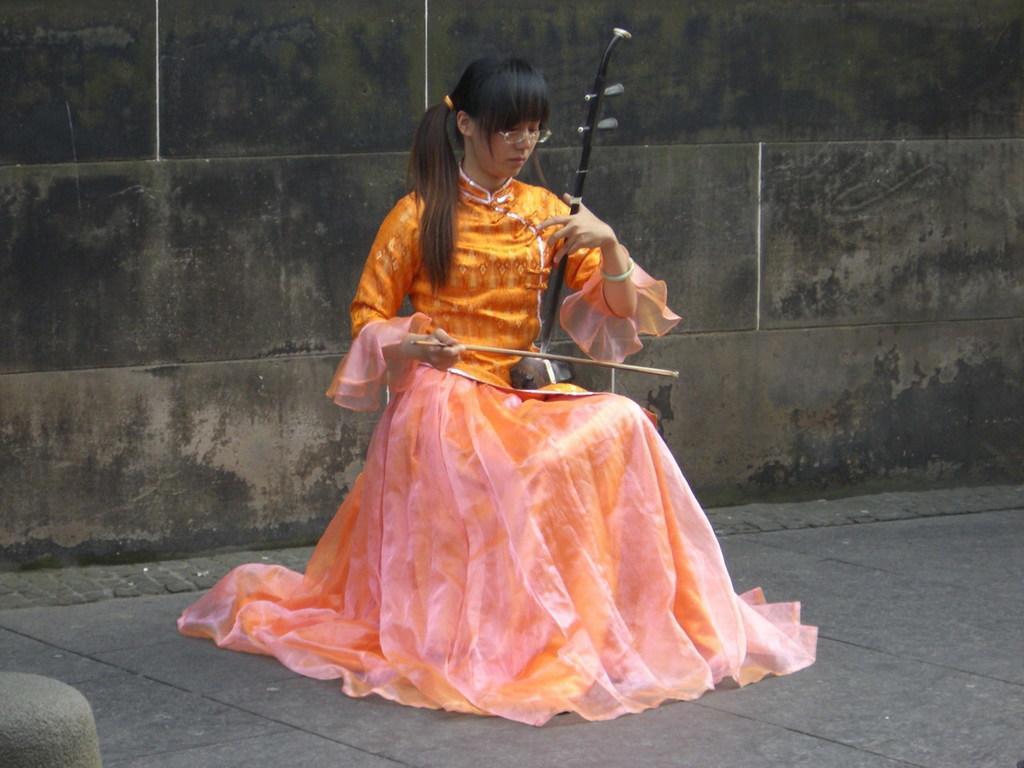Can you describe this image briefly? This image is taken outdoors. At the bottom of the image there is a floor. In the background there is a wall. In the middle of the image a girl is sitting on the chair and playing music with a musical instrument. 